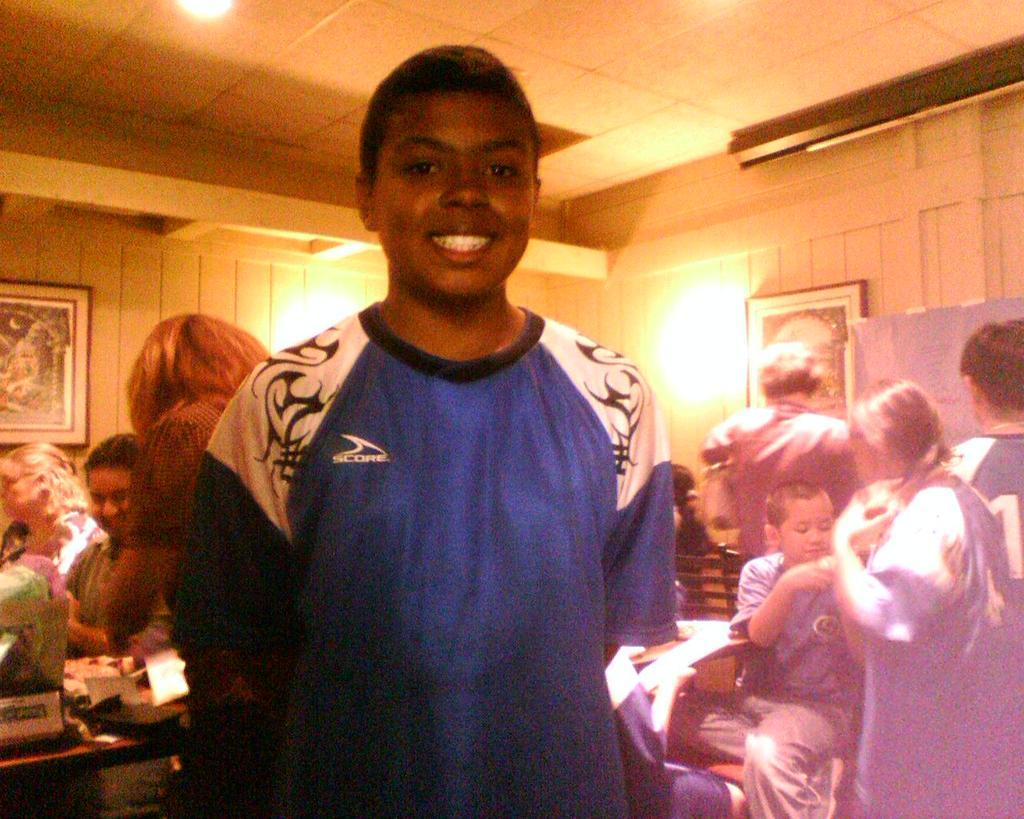What are the people in the image doing? The people in the image are standing and sitting. What can be seen in the background of the image? There is a wall in the backdrop of the image. What is on the wall in the image? There is a photo frame and a lamp on the wall. What type of sack is being used by the dad in the image? There is no dad or sack present in the image. What level of difficulty is the game being played at in the image? There is no game or level of difficulty mentioned in the image. 